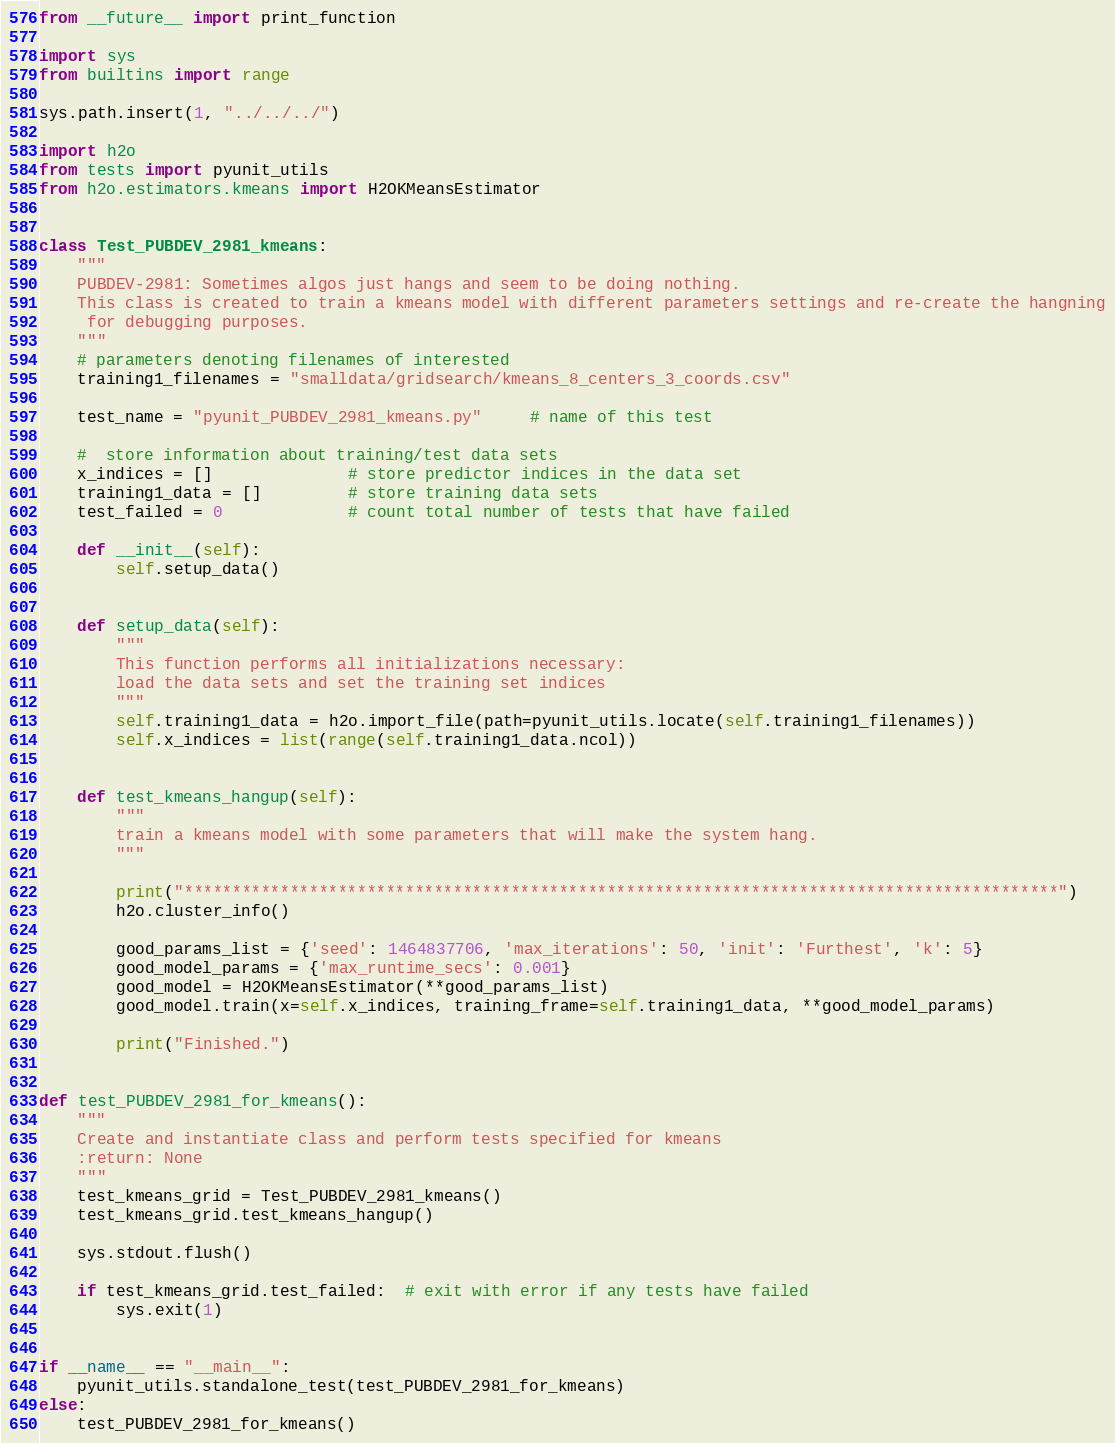Convert code to text. <code><loc_0><loc_0><loc_500><loc_500><_Python_>from __future__ import print_function

import sys
from builtins import range

sys.path.insert(1, "../../../")

import h2o
from tests import pyunit_utils
from h2o.estimators.kmeans import H2OKMeansEstimator


class Test_PUBDEV_2981_kmeans:
    """
    PUBDEV-2981: Sometimes algos just hangs and seem to be doing nothing.
    This class is created to train a kmeans model with different parameters settings and re-create the hangning
     for debugging purposes.
    """
    # parameters denoting filenames of interested
    training1_filenames = "smalldata/gridsearch/kmeans_8_centers_3_coords.csv"

    test_name = "pyunit_PUBDEV_2981_kmeans.py"     # name of this test

    #  store information about training/test data sets
    x_indices = []              # store predictor indices in the data set
    training1_data = []         # store training data sets
    test_failed = 0             # count total number of tests that have failed

    def __init__(self):
        self.setup_data()


    def setup_data(self):
        """
        This function performs all initializations necessary:
        load the data sets and set the training set indices
        """
        self.training1_data = h2o.import_file(path=pyunit_utils.locate(self.training1_filenames))
        self.x_indices = list(range(self.training1_data.ncol))


    def test_kmeans_hangup(self):
        """
        train a kmeans model with some parameters that will make the system hang.
        """

        print("*******************************************************************************************")
        h2o.cluster_info()

        good_params_list = {'seed': 1464837706, 'max_iterations': 50, 'init': 'Furthest', 'k': 5}
        good_model_params = {'max_runtime_secs': 0.001}
        good_model = H2OKMeansEstimator(**good_params_list)
        good_model.train(x=self.x_indices, training_frame=self.training1_data, **good_model_params)

        print("Finished.")


def test_PUBDEV_2981_for_kmeans():
    """
    Create and instantiate class and perform tests specified for kmeans
    :return: None
    """
    test_kmeans_grid = Test_PUBDEV_2981_kmeans()
    test_kmeans_grid.test_kmeans_hangup()

    sys.stdout.flush()

    if test_kmeans_grid.test_failed:  # exit with error if any tests have failed
        sys.exit(1)


if __name__ == "__main__":
    pyunit_utils.standalone_test(test_PUBDEV_2981_for_kmeans)
else:
    test_PUBDEV_2981_for_kmeans()</code> 